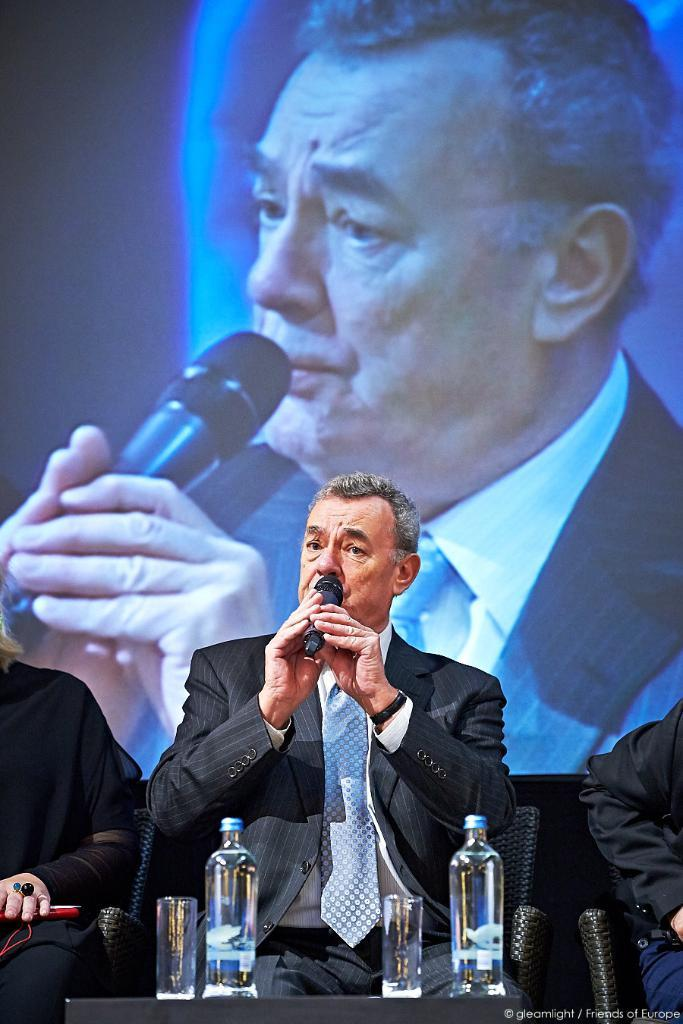What is the man in the image doing? The man is sitting on a chair in the image. What is the man holding in the image? The man is holding a microphone in the image. What can be seen on the table in the image? There are water bottles and glasses on the table in the image. What type of chain is hanging from the ceiling in the image? There is no chain hanging from the ceiling in the image. 